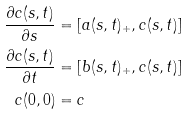Convert formula to latex. <formula><loc_0><loc_0><loc_500><loc_500>\frac { \partial c ( s , t ) } { \partial s } & = [ a ( s , t ) _ { + } , c ( s , t ) ] \\ \frac { \partial c ( s , t ) } { \partial t } & = [ b ( s , t ) _ { + } , c ( s , t ) ] \\ c ( 0 , 0 ) & = c</formula> 